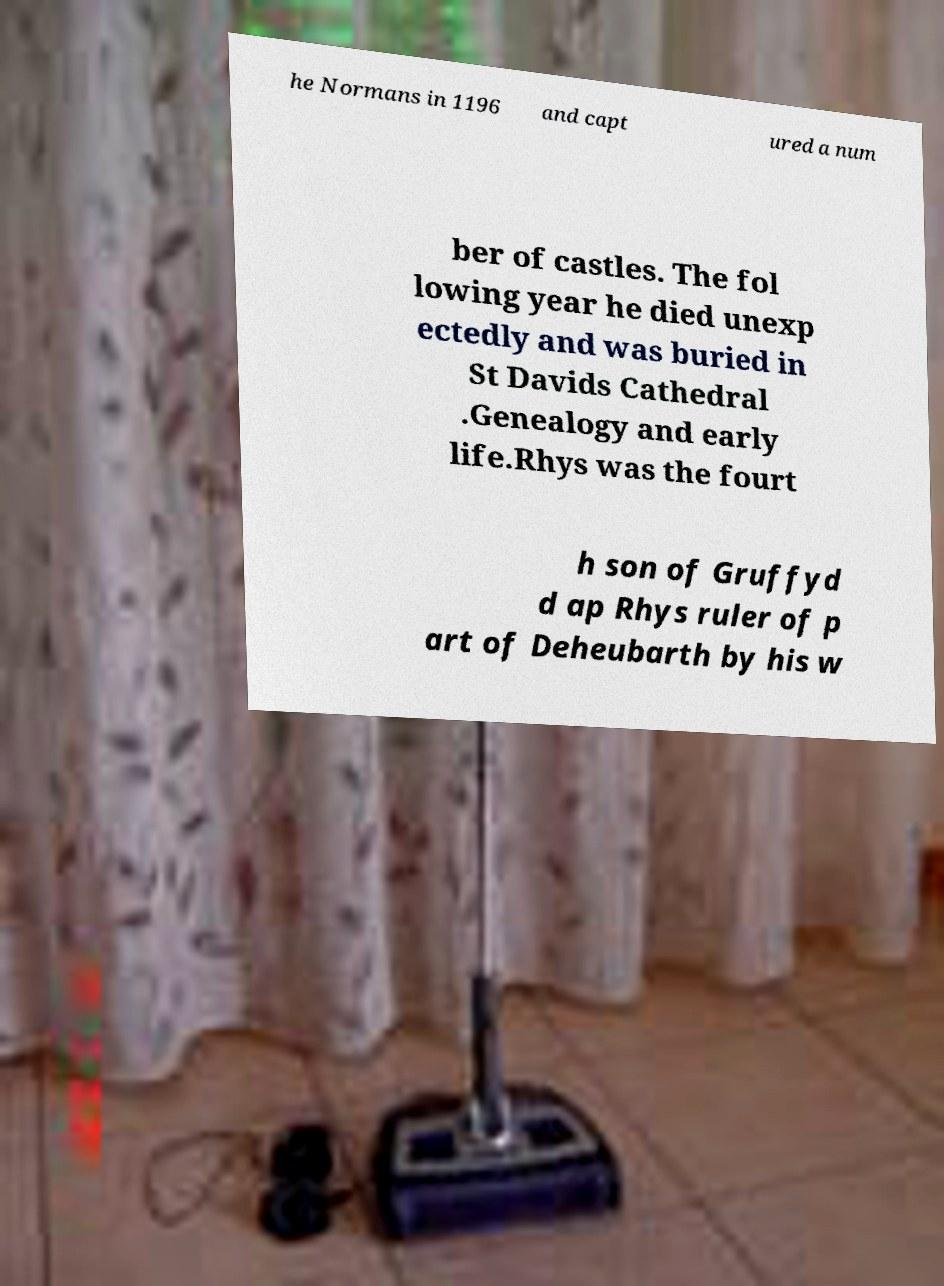I need the written content from this picture converted into text. Can you do that? he Normans in 1196 and capt ured a num ber of castles. The fol lowing year he died unexp ectedly and was buried in St Davids Cathedral .Genealogy and early life.Rhys was the fourt h son of Gruffyd d ap Rhys ruler of p art of Deheubarth by his w 